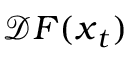<formula> <loc_0><loc_0><loc_500><loc_500>\mathcal { D } F ( x _ { t } )</formula> 